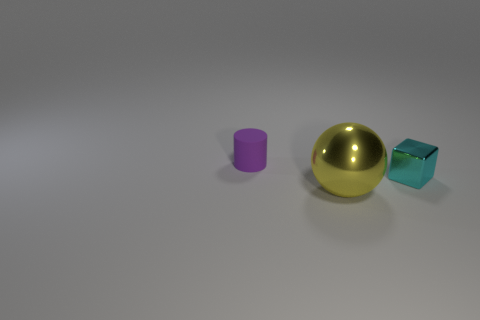Add 2 red blocks. How many objects exist? 5 Subtract all balls. How many objects are left? 2 Subtract all big brown things. Subtract all small cyan metallic cubes. How many objects are left? 2 Add 3 cyan shiny blocks. How many cyan shiny blocks are left? 4 Add 3 small purple objects. How many small purple objects exist? 4 Subtract 0 brown cylinders. How many objects are left? 3 